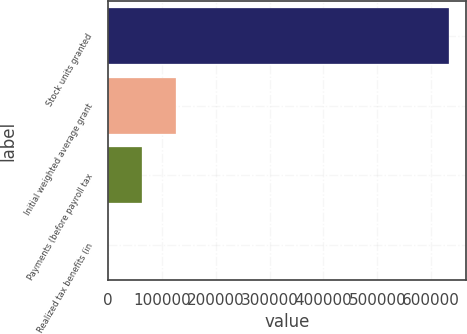Convert chart to OTSL. <chart><loc_0><loc_0><loc_500><loc_500><bar_chart><fcel>Stock units granted<fcel>Initial weighted average grant<fcel>Payments (before payroll tax<fcel>Realized tax benefits (in<nl><fcel>632261<fcel>126460<fcel>63234.7<fcel>9.5<nl></chart> 